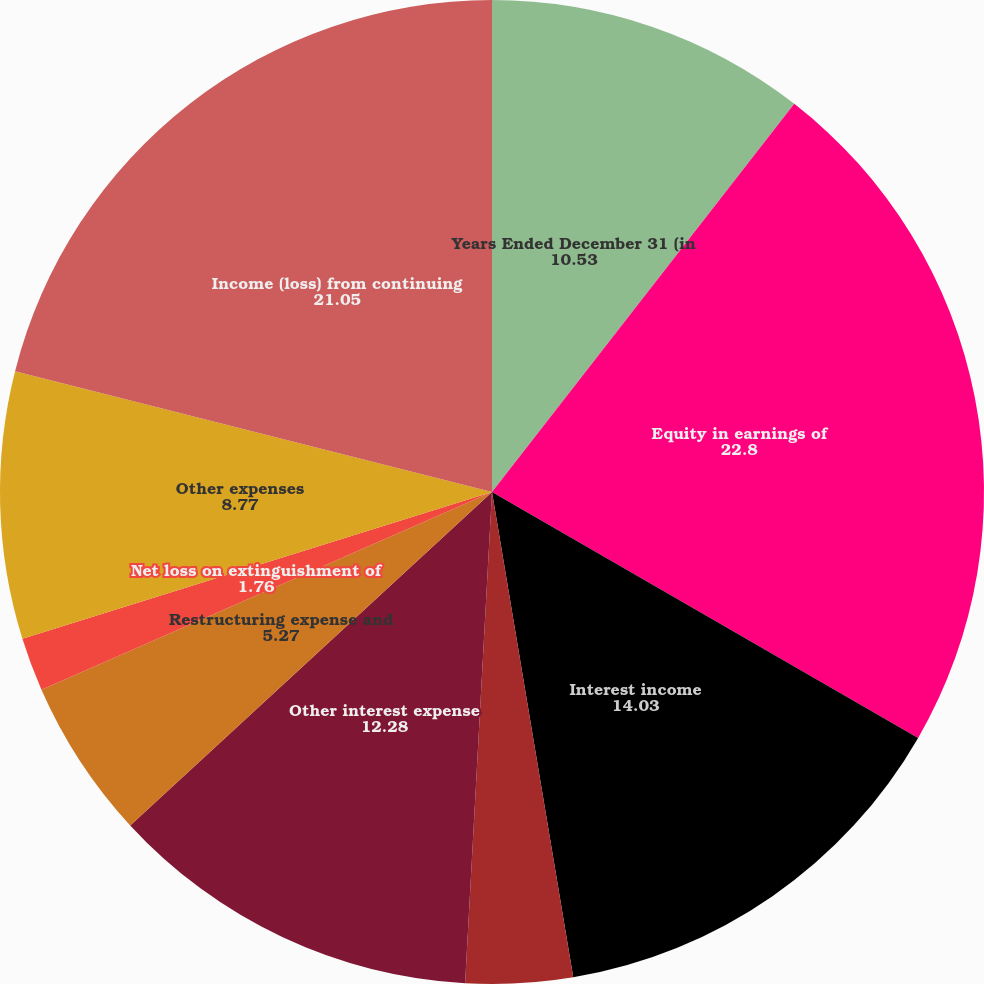Convert chart. <chart><loc_0><loc_0><loc_500><loc_500><pie_chart><fcel>Years Ended December 31 (in<fcel>Equity in earnings of<fcel>Interest income<fcel>Net realized capital gains<fcel>Other income<fcel>Other interest expense<fcel>Restructuring expense and<fcel>Net loss on extinguishment of<fcel>Other expenses<fcel>Income (loss) from continuing<nl><fcel>10.53%<fcel>22.8%<fcel>14.03%<fcel>3.51%<fcel>0.0%<fcel>12.28%<fcel>5.27%<fcel>1.76%<fcel>8.77%<fcel>21.05%<nl></chart> 